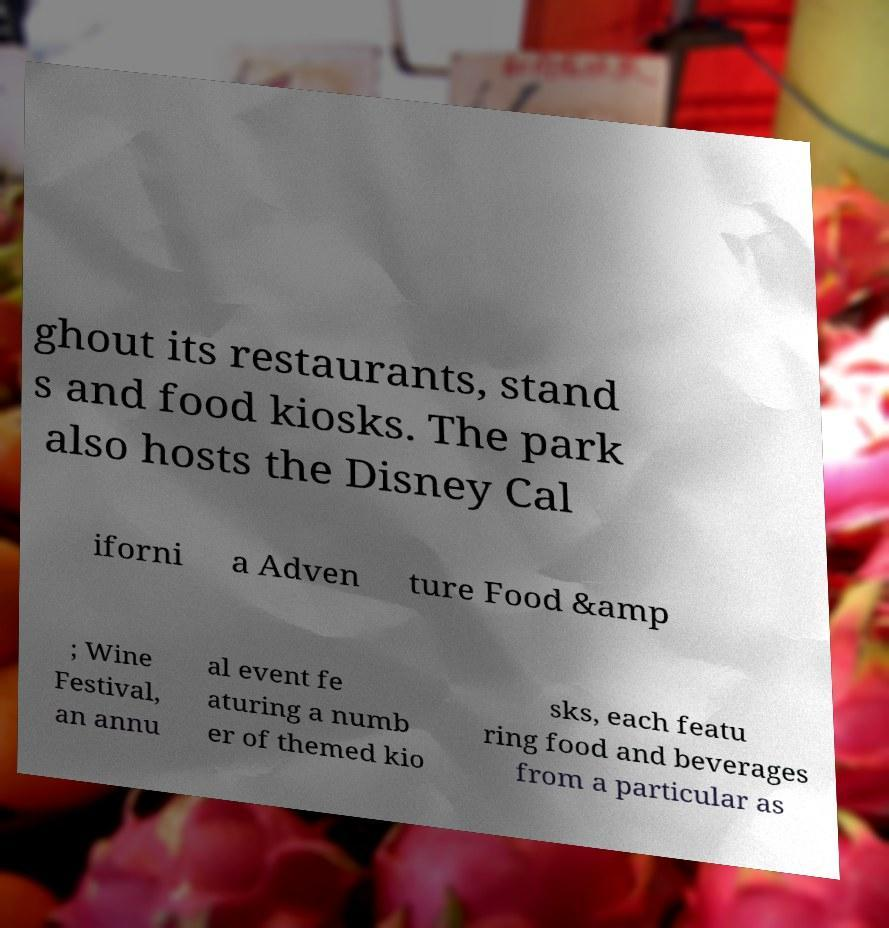For documentation purposes, I need the text within this image transcribed. Could you provide that? ghout its restaurants, stand s and food kiosks. The park also hosts the Disney Cal iforni a Adven ture Food &amp ; Wine Festival, an annu al event fe aturing a numb er of themed kio sks, each featu ring food and beverages from a particular as 